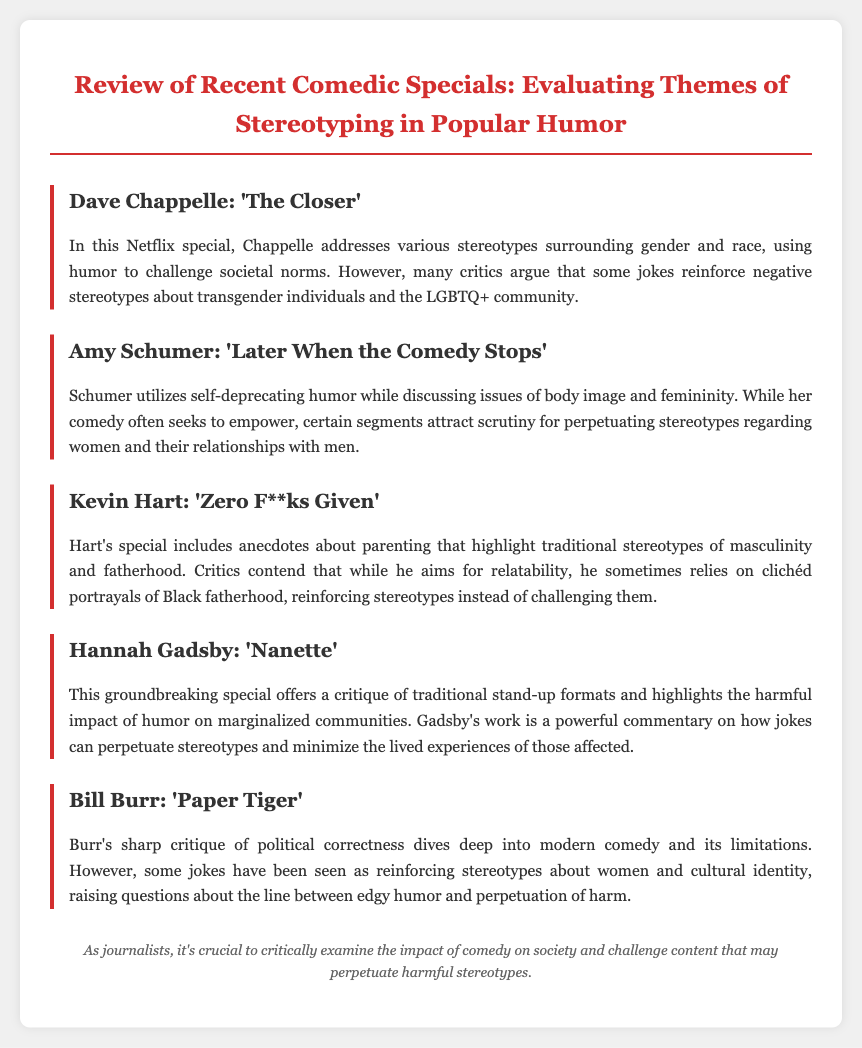What is the title of the review? The title of the review is given in the header of the document.
Answer: Review of Recent Comedic Specials: Evaluating Themes of Stereotyping in Popular Humor Who is the comedian discussed in ‘The Closer’? The menu item directly mentions the comedian featured in that special.
Answer: Dave Chappelle What issue does Amy Schumer address in her special? The document explains the theme of Amy Schumer's comedy in relation to societal issues.
Answer: Body image Which comedian's special is described as a critique of political correctness? The menu defines a specific comedian known for addressing political correctness in their comedy.
Answer: Bill Burr What common theme is examined in Kevin Hart's special? The text summarizes the primary stereotype highlighted in Hart's anecdotes about parenting.
Answer: Masculinity How does Hannah Gadsby approach humor in ‘Nanette’? The document outlines Gadsby’s unique method of addressing humor and stereotypes in her special.
Answer: Critique of traditional stand-up formats Which comedian's special reinforces stereotypes about Black fatherhood? The answer requires integrating information from the segment on Kevin Hart.
Answer: Kevin Hart What type of humor does Dave Chappelle use to challenge societal norms? The document indicates the approach Chappelle takes in his Netflix special.
Answer: Humor 